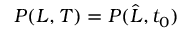Convert formula to latex. <formula><loc_0><loc_0><loc_500><loc_500>P ( L , T ) = P ( \widehat { L } , t _ { 0 } )</formula> 